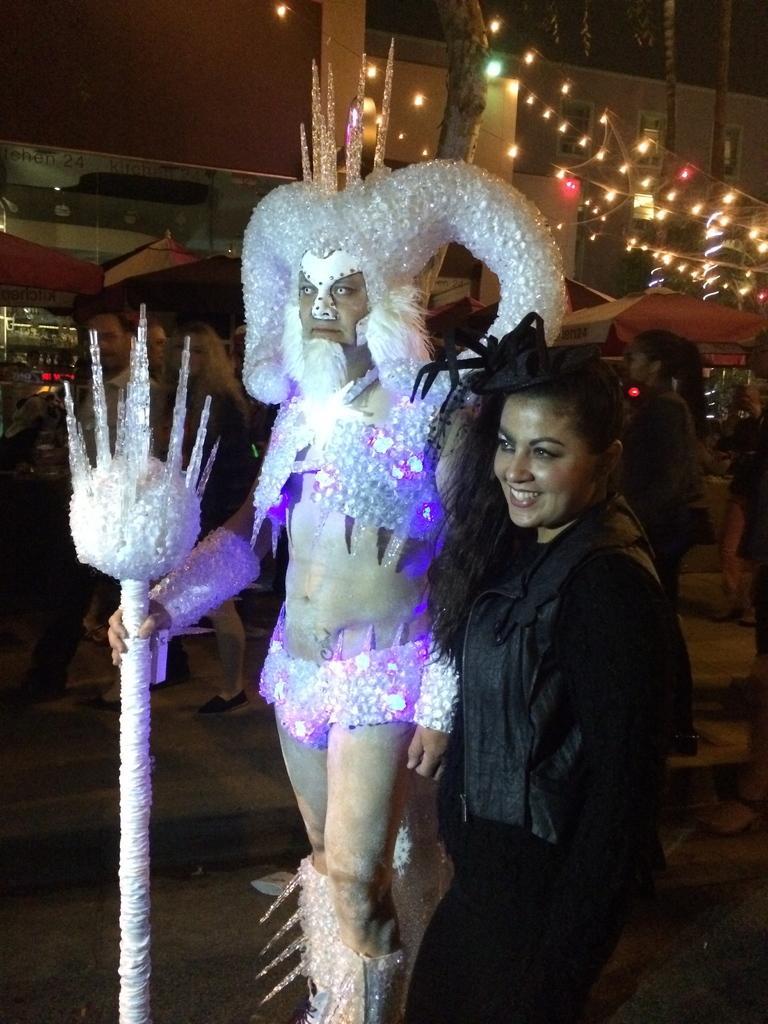In one or two sentences, can you explain what this image depicts? In this image there are two persons, they are wearing costumes, in the background there are people walking on the road and there are shops, lightings. 